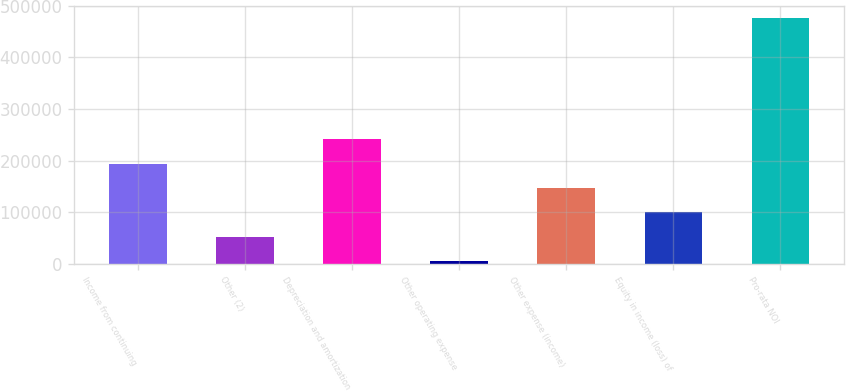Convert chart to OTSL. <chart><loc_0><loc_0><loc_500><loc_500><bar_chart><fcel>Income from continuing<fcel>Other (2)<fcel>Depreciation and amortization<fcel>Other operating expense<fcel>Other expense (income)<fcel>Equity in income (loss) of<fcel>Pro-rata NOI<nl><fcel>193919<fcel>52584.6<fcel>241031<fcel>5473<fcel>146808<fcel>99696.2<fcel>476589<nl></chart> 